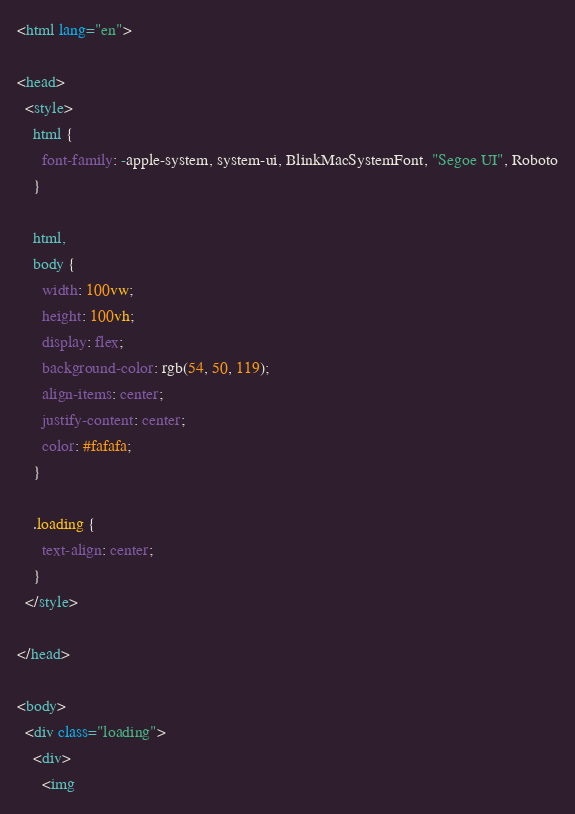Convert code to text. <code><loc_0><loc_0><loc_500><loc_500><_HTML_><html lang="en">

<head>
  <style>
    html {
      font-family: -apple-system, system-ui, BlinkMacSystemFont, "Segoe UI", Roboto
    }

    html,
    body {
      width: 100vw;
      height: 100vh;
      display: flex;
      background-color: rgb(54, 50, 119);
      align-items: center;
      justify-content: center;
      color: #fafafa;
    }

    .loading {
      text-align: center;
    }
  </style>

</head>

<body>
  <div class="loading">
    <div>
      <img</code> 